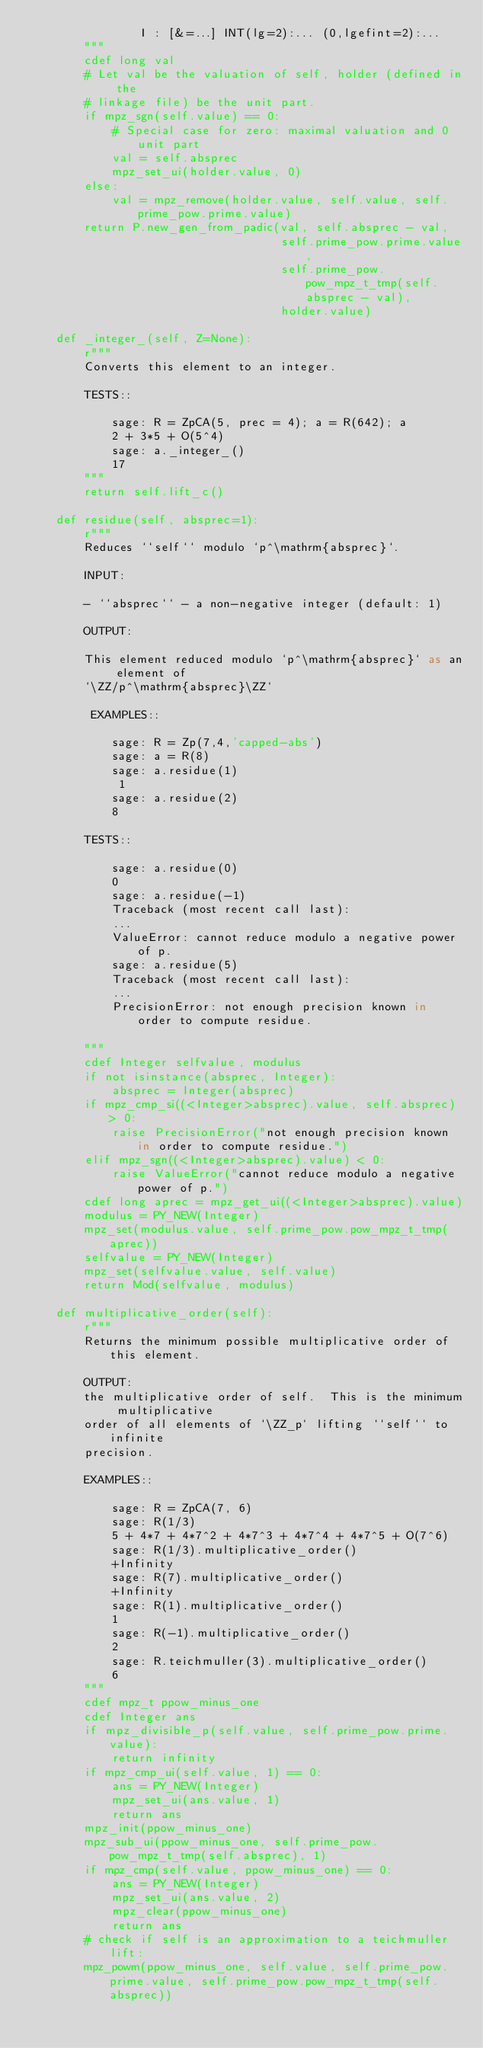Convert code to text. <code><loc_0><loc_0><loc_500><loc_500><_Cython_>                I : [&=...] INT(lg=2):... (0,lgefint=2):... 
        """
        cdef long val
        # Let val be the valuation of self, holder (defined in the
        # linkage file) be the unit part.
        if mpz_sgn(self.value) == 0:
            # Special case for zero: maximal valuation and 0 unit part
            val = self.absprec
            mpz_set_ui(holder.value, 0)
        else:
            val = mpz_remove(holder.value, self.value, self.prime_pow.prime.value)
        return P.new_gen_from_padic(val, self.absprec - val,
                                    self.prime_pow.prime.value,
                                    self.prime_pow.pow_mpz_t_tmp(self.absprec - val),
                                    holder.value)

    def _integer_(self, Z=None):
        r"""
        Converts this element to an integer.

        TESTS::

            sage: R = ZpCA(5, prec = 4); a = R(642); a
            2 + 3*5 + O(5^4)
            sage: a._integer_()
            17
        """
        return self.lift_c()

    def residue(self, absprec=1):
        r"""
        Reduces ``self`` modulo `p^\mathrm{absprec}`.

        INPUT:

        - ``absprec`` - a non-negative integer (default: 1)

        OUTPUT:

        This element reduced modulo `p^\mathrm{absprec}` as an element of
        `\ZZ/p^\mathrm{absprec}\ZZ`

         EXAMPLES::

            sage: R = Zp(7,4,'capped-abs')
            sage: a = R(8)
            sage: a.residue(1)
             1
            sage: a.residue(2)
            8

        TESTS::

            sage: a.residue(0)
            0
            sage: a.residue(-1)
            Traceback (most recent call last):
            ...
            ValueError: cannot reduce modulo a negative power of p.
            sage: a.residue(5)
            Traceback (most recent call last):
            ...
            PrecisionError: not enough precision known in order to compute residue.

        """
        cdef Integer selfvalue, modulus
        if not isinstance(absprec, Integer):
            absprec = Integer(absprec)
        if mpz_cmp_si((<Integer>absprec).value, self.absprec) > 0:
            raise PrecisionError("not enough precision known in order to compute residue.")
        elif mpz_sgn((<Integer>absprec).value) < 0:
            raise ValueError("cannot reduce modulo a negative power of p.")
        cdef long aprec = mpz_get_ui((<Integer>absprec).value)
        modulus = PY_NEW(Integer)
        mpz_set(modulus.value, self.prime_pow.pow_mpz_t_tmp(aprec))
        selfvalue = PY_NEW(Integer)
        mpz_set(selfvalue.value, self.value)
        return Mod(selfvalue, modulus)

    def multiplicative_order(self):
        r"""
        Returns the minimum possible multiplicative order of this element.

        OUTPUT:
        the multiplicative order of self.  This is the minimum multiplicative
        order of all elements of `\ZZ_p` lifting ``self`` to infinite
        precision.

        EXAMPLES::

            sage: R = ZpCA(7, 6)
            sage: R(1/3)
            5 + 4*7 + 4*7^2 + 4*7^3 + 4*7^4 + 4*7^5 + O(7^6)
            sage: R(1/3).multiplicative_order()
            +Infinity
            sage: R(7).multiplicative_order()
            +Infinity
            sage: R(1).multiplicative_order()
            1
            sage: R(-1).multiplicative_order()
            2
            sage: R.teichmuller(3).multiplicative_order()
            6
        """
        cdef mpz_t ppow_minus_one
        cdef Integer ans
        if mpz_divisible_p(self.value, self.prime_pow.prime.value):
            return infinity
        if mpz_cmp_ui(self.value, 1) == 0:
            ans = PY_NEW(Integer)
            mpz_set_ui(ans.value, 1)
            return ans
        mpz_init(ppow_minus_one)
        mpz_sub_ui(ppow_minus_one, self.prime_pow.pow_mpz_t_tmp(self.absprec), 1)
        if mpz_cmp(self.value, ppow_minus_one) == 0:
            ans = PY_NEW(Integer)
            mpz_set_ui(ans.value, 2)
            mpz_clear(ppow_minus_one)
            return ans
        # check if self is an approximation to a teichmuller lift:
        mpz_powm(ppow_minus_one, self.value, self.prime_pow.prime.value, self.prime_pow.pow_mpz_t_tmp(self.absprec))</code> 